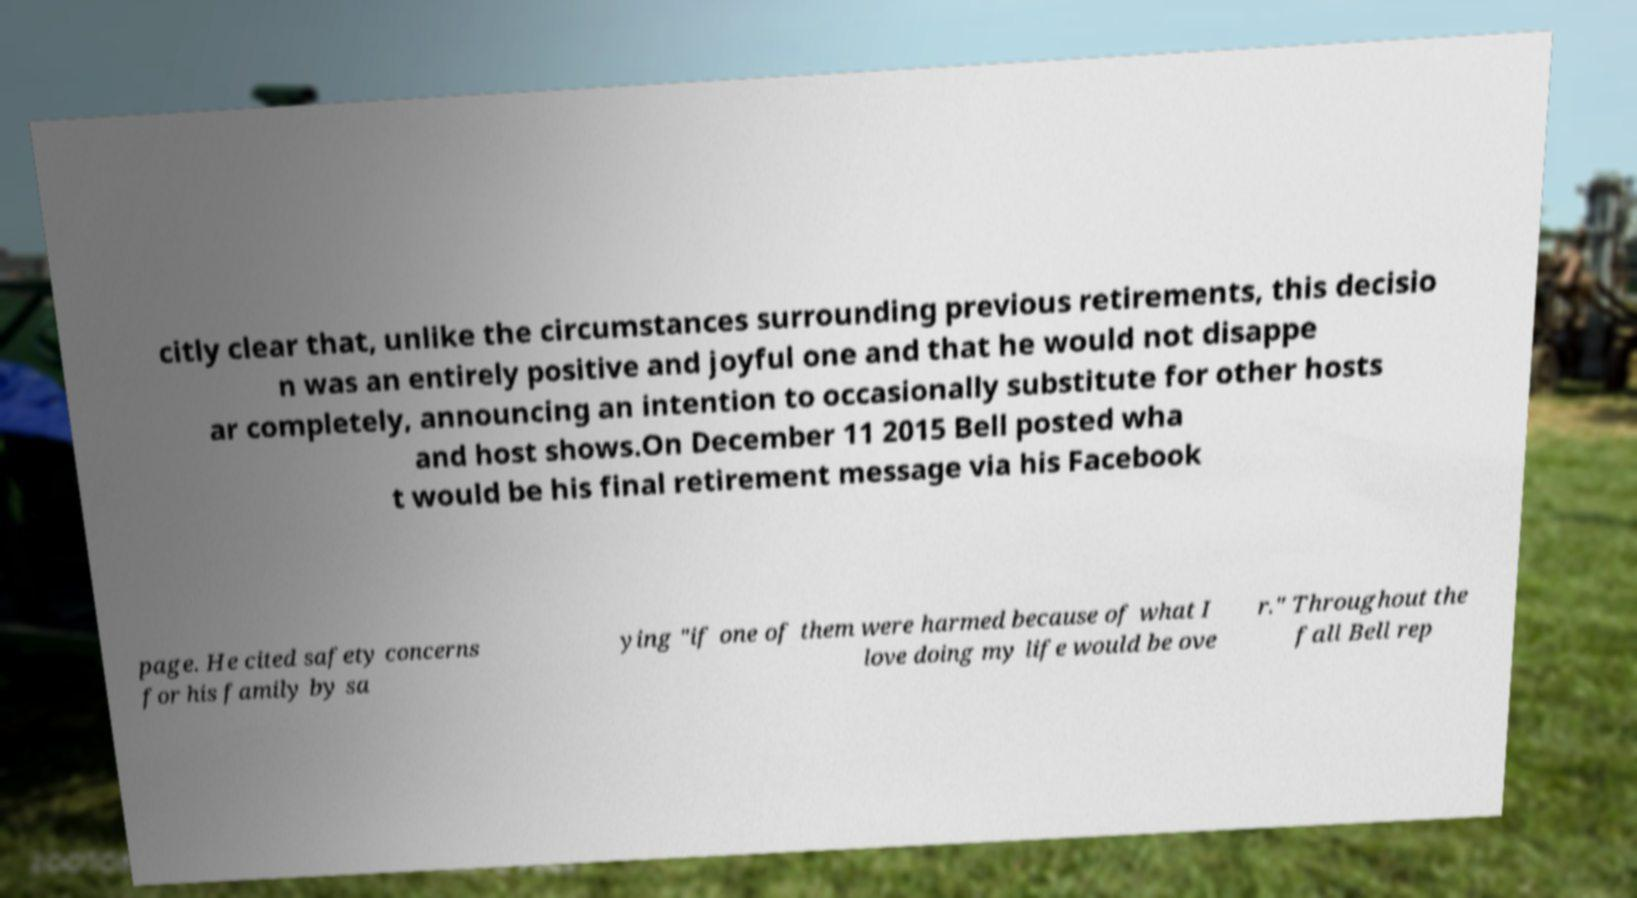Could you assist in decoding the text presented in this image and type it out clearly? citly clear that, unlike the circumstances surrounding previous retirements, this decisio n was an entirely positive and joyful one and that he would not disappe ar completely, announcing an intention to occasionally substitute for other hosts and host shows.On December 11 2015 Bell posted wha t would be his final retirement message via his Facebook page. He cited safety concerns for his family by sa ying "if one of them were harmed because of what I love doing my life would be ove r." Throughout the fall Bell rep 